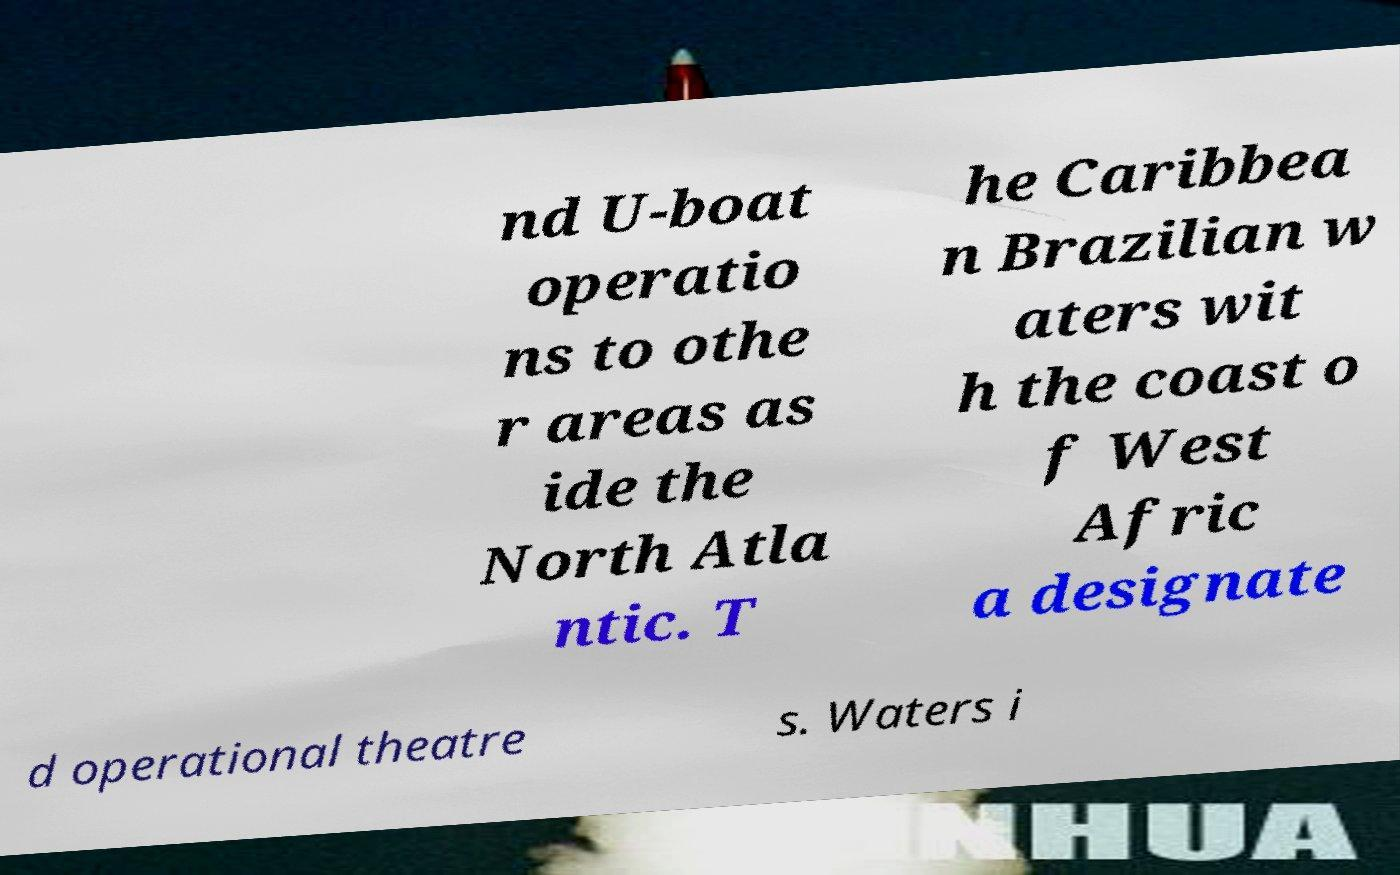Please identify and transcribe the text found in this image. nd U-boat operatio ns to othe r areas as ide the North Atla ntic. T he Caribbea n Brazilian w aters wit h the coast o f West Afric a designate d operational theatre s. Waters i 